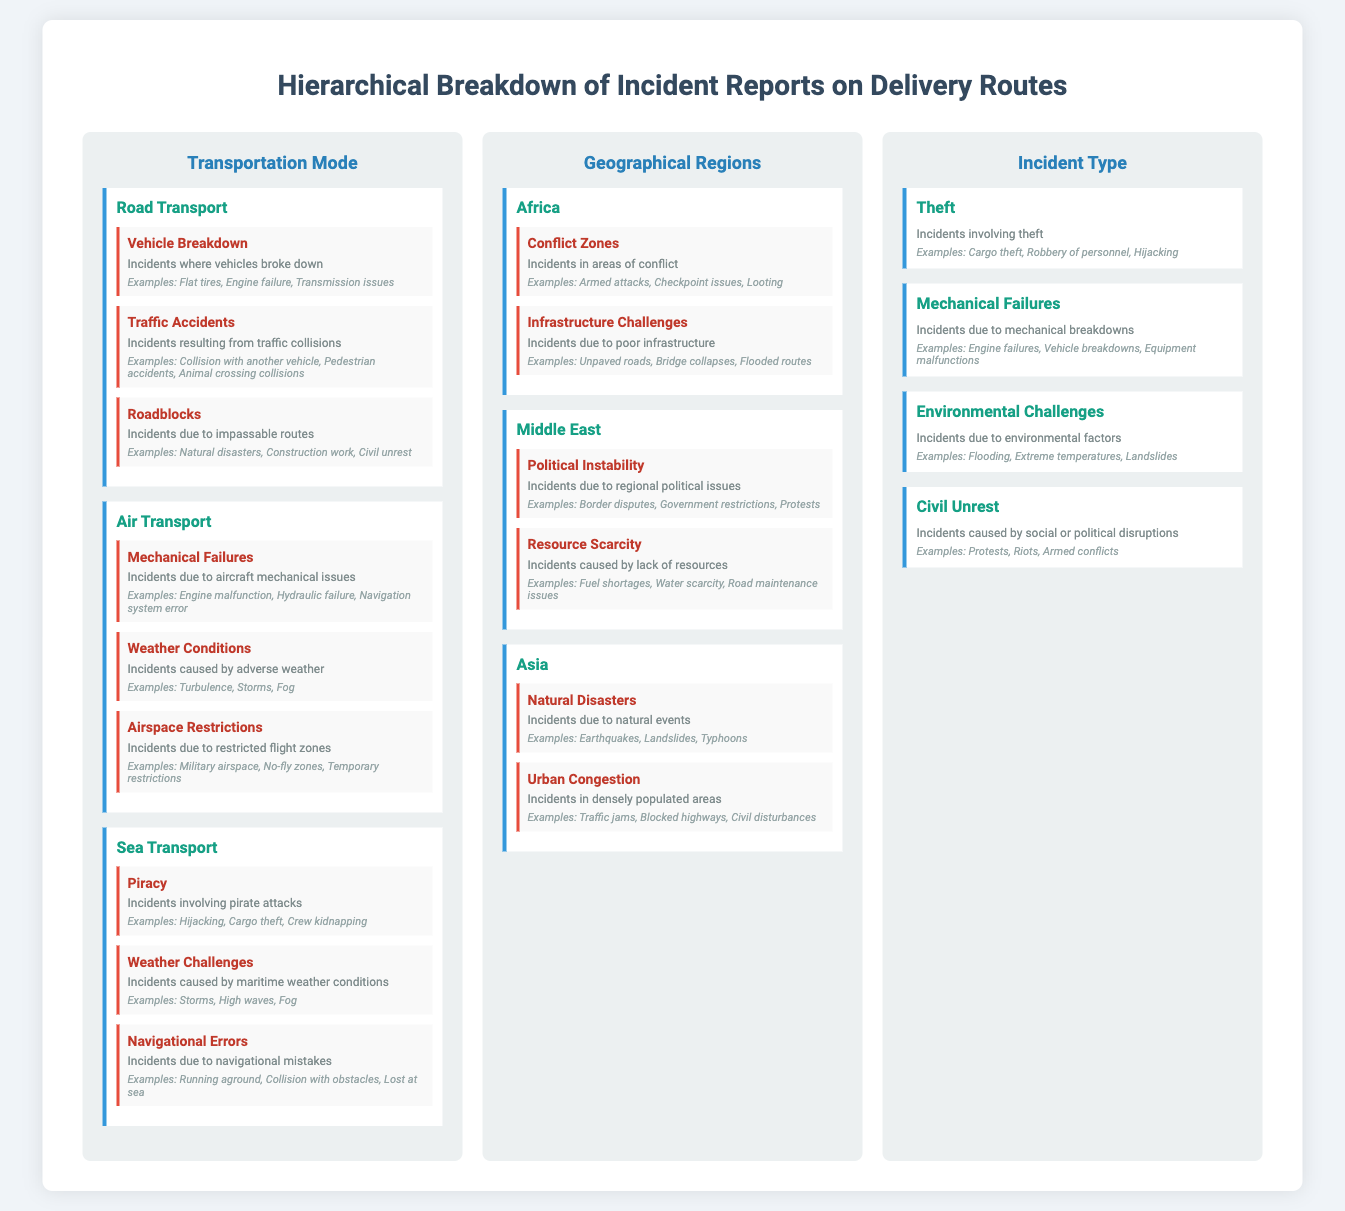What are the three modes of transport listed? The document lists three modes of transport under the Transportation Mode branch: Road Transport, Air Transport, and Sea Transport.
Answer: Road Transport, Air Transport, Sea Transport What type of incidents are classified under Road Transport? The incidents listed under Road Transport include Vehicle Breakdown, Traffic Accidents, and Roadblocks.
Answer: Vehicle Breakdown, Traffic Accidents, Roadblocks Which sub-branch includes incidents due to natural events? The sub-branch that includes incidents due to natural events is Natural Disasters, which is under the Asia region.
Answer: Natural Disasters How many examples are provided for Mechanical Failures under Air Transport? The document provides three examples for Mechanical Failures: Engine malfunction, Hydraulic failure, and Navigation system error, indicating multiple issues.
Answer: Three examples What is the primary cause of incidents in Conflict Zones under Africa? Incidents in Conflict Zones are primarily due to armed attacks, checkpoint issues, and looting.
Answer: Armed attacks, Checkpoint issues, Looting Which geographical region is associated with Political Instability incidents? The geographical region associated with Political Instability incidents is the Middle East.
Answer: Middle East How is the Civil Unrest incident type described? Civil Unrest is described as incidents caused by social or political disruptions.
Answer: Social or political disruptions What type of incidents does the Theft sub-branch cover? The Theft sub-branch covers incidents involving theft such as cargo theft and robbery of personnel.
Answer: Incidents involving theft What are the primary challenges faced in the Sea Transport category? The primary challenges faced in the Sea Transport category include Piracy, Weather Challenges, and Navigational Errors.
Answer: Piracy, Weather Challenges, Navigational Errors 